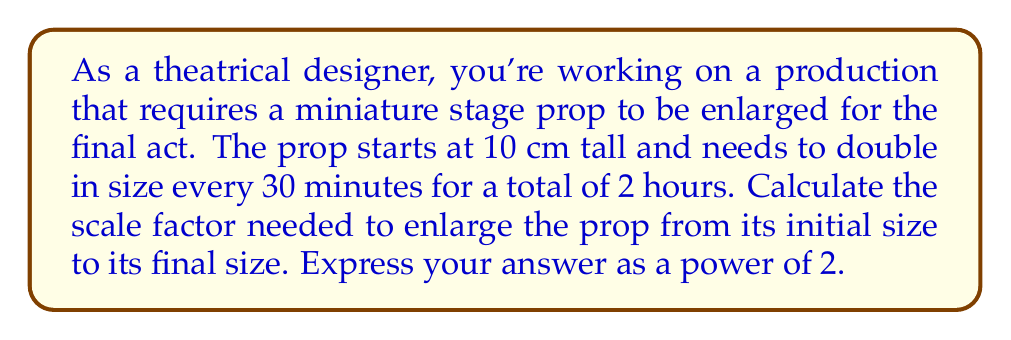Could you help me with this problem? Let's approach this step-by-step:

1) First, we need to determine how many times the prop will double in size:
   - The prop doubles every 30 minutes
   - The total time is 2 hours = 120 minutes
   - Number of doublings = 120 minutes ÷ 30 minutes = 4

2) Now, we can express this as an exponential growth function:
   $$ \text{Final size} = \text{Initial size} \times 2^n $$
   where $n$ is the number of doublings

3) In this case:
   $$ \text{Final size} = 10 \text{ cm} \times 2^4 $$

4) The scale factor is the ratio of the final size to the initial size:
   $$ \text{Scale factor} = \frac{\text{Final size}}{\text{Initial size}} = \frac{10 \text{ cm} \times 2^4}{10 \text{ cm}} $$

5) The 10 cm cancels out:
   $$ \text{Scale factor} = 2^4 $$

Therefore, the scale factor is $2^4$, which equals 16. This means the final prop will be 16 times larger than the initial prop.
Answer: $2^4$ 